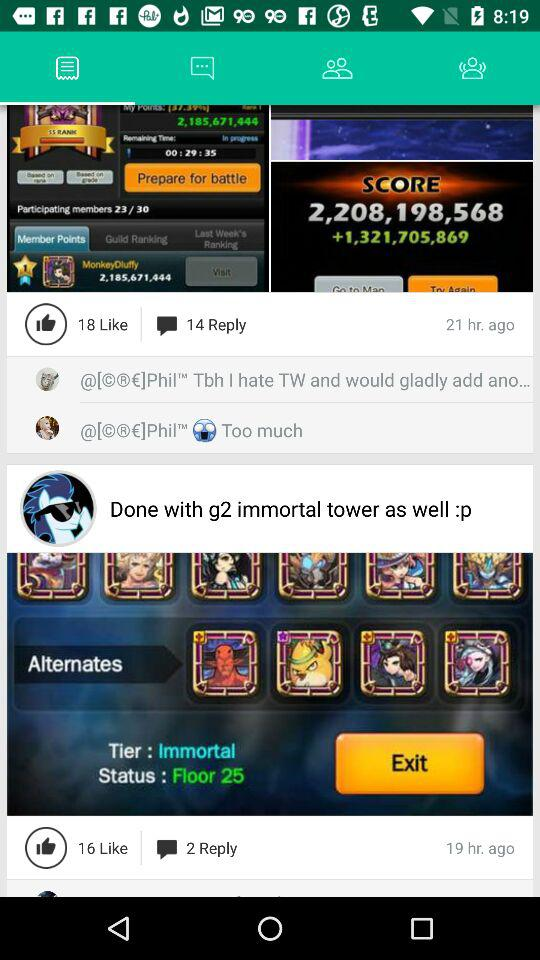How long ago was the "Done with g2 immortal tower as well :p" posted? It was posted 19 hours ago. 